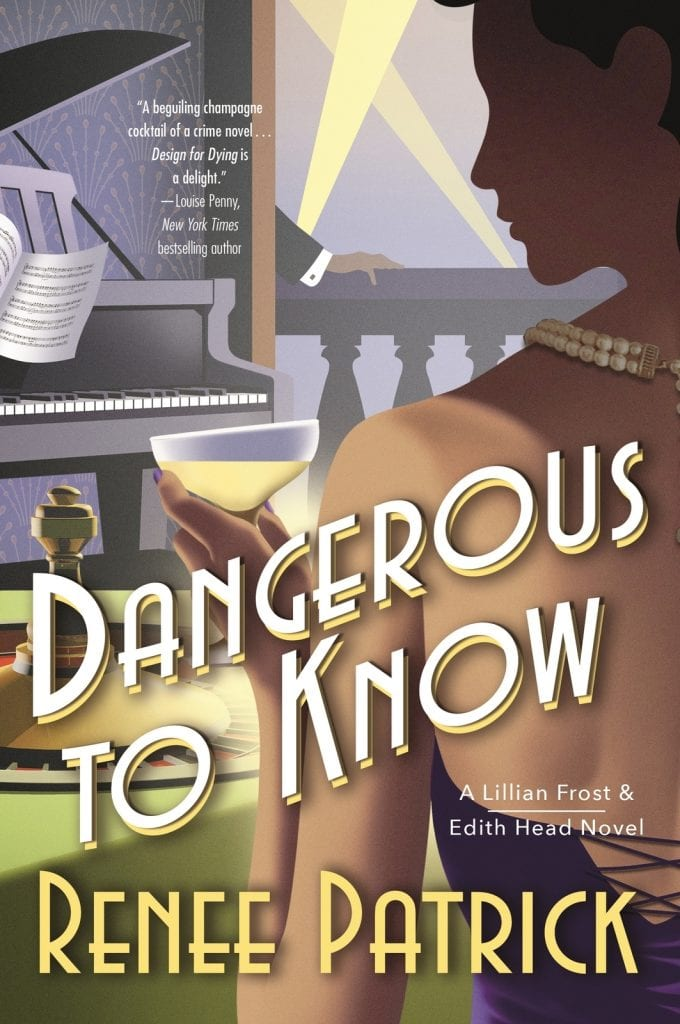What genre does the quoted review by Louise Penny hint the book belongs to? The review by Louise Penny describes the book as "a beguiling champagne cocktail of a crime novel," clearly hinting at the mystery or crime genre. The term 'cocktail' suggests a stylish blend of narrative techniques or themes, potentially weaving together elements of intrigue, suspense, and elegance associated with high society or sophisticated events, much like a well-mixed drink. 